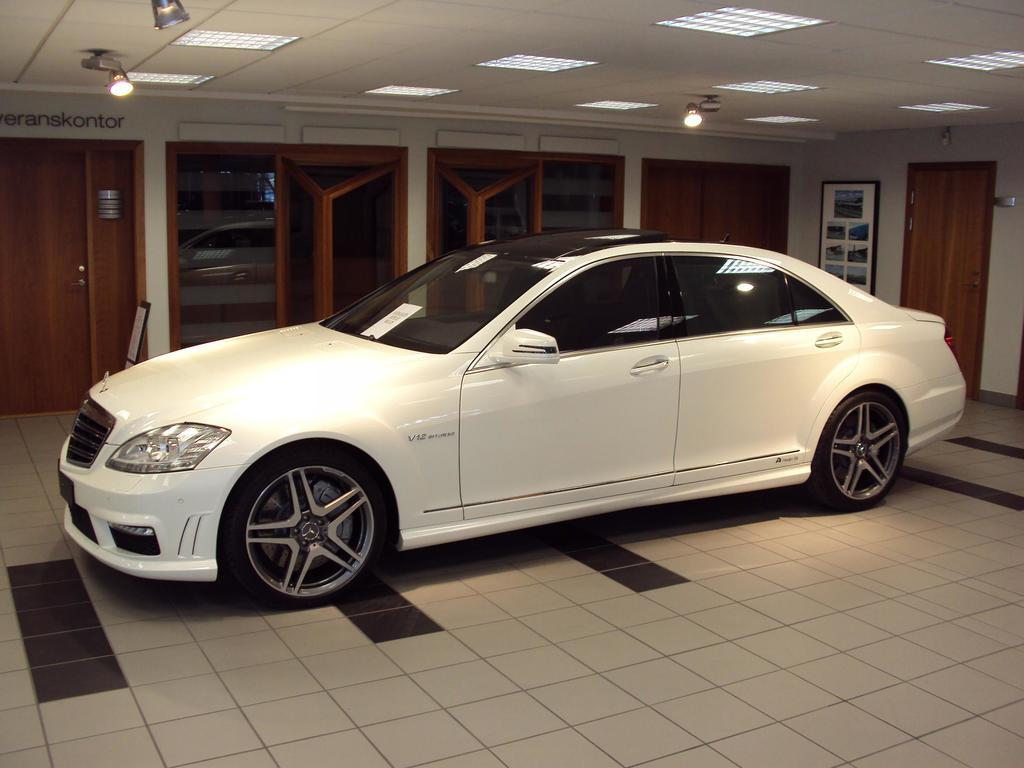What type of vehicle is in the image? There is a white car in the image. Where is the car located? The car is inside a room. What is the flooring material in the room? The room has a tiled floor. What can be seen on the ceiling of the room? There are lights on the ceiling. How many doors are visible on the wall in the background? There are multiple doors on the wall in the background. What type of disgusting smell can be detected in the image? There is no mention of any smell in the image, so it cannot be determined if there is a disgusting smell present. 